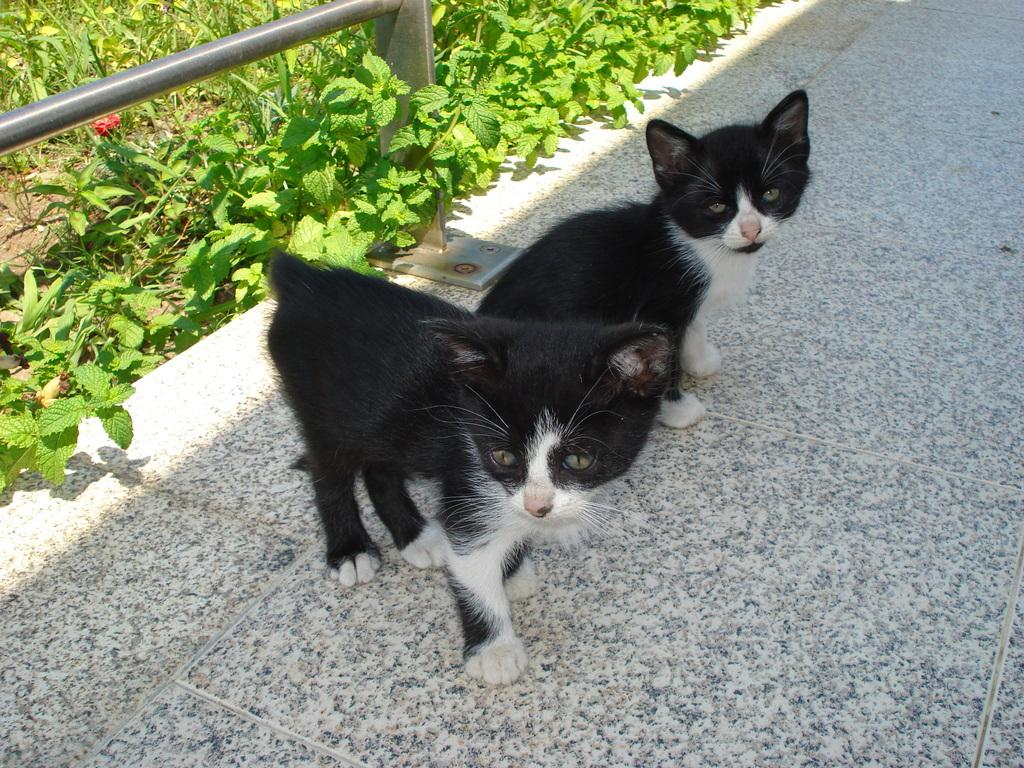What type of animals are on the tile surface in the image? There are kittens on the tile surface in the image. What color are the kittens? The kittens are in black and white color. What can be seen in the left side corner of the image? On the left side corner of the image, there are rods and plants. What type of fruit is the kitty holding in the image? There is no kitty or fruit present in the image; it features kittens in black and white color on a tile surface. 